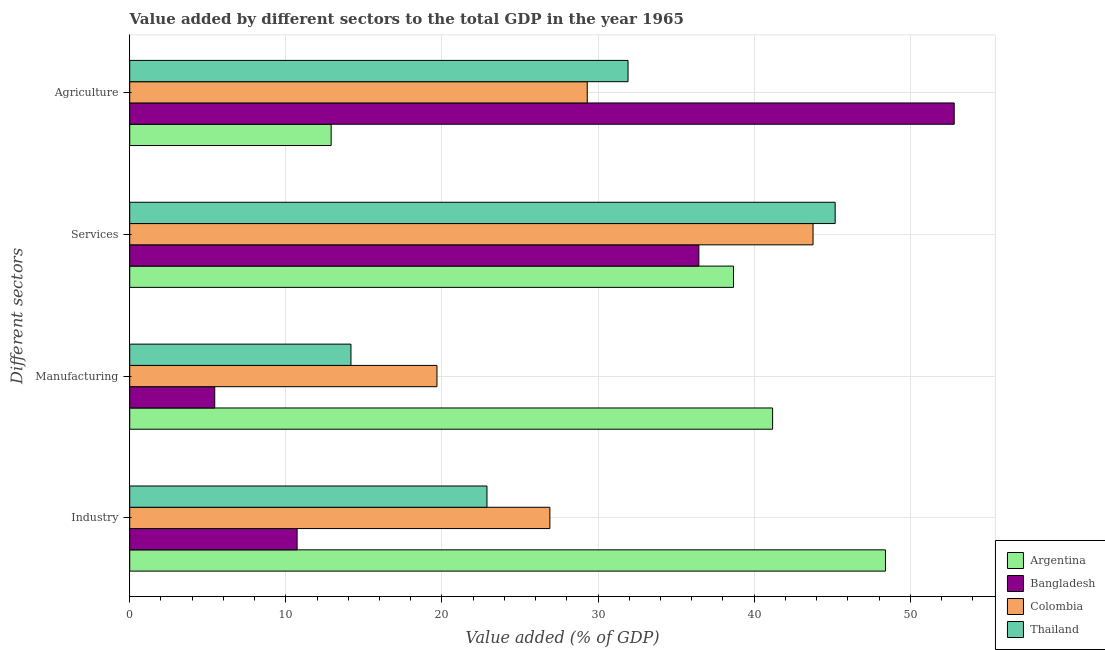How many different coloured bars are there?
Your answer should be compact. 4. How many groups of bars are there?
Provide a short and direct response. 4. Are the number of bars on each tick of the Y-axis equal?
Offer a terse response. Yes. What is the label of the 1st group of bars from the top?
Offer a terse response. Agriculture. What is the value added by services sector in Colombia?
Offer a very short reply. 43.77. Across all countries, what is the maximum value added by industrial sector?
Provide a succinct answer. 48.41. Across all countries, what is the minimum value added by industrial sector?
Give a very brief answer. 10.72. In which country was the value added by manufacturing sector minimum?
Give a very brief answer. Bangladesh. What is the total value added by manufacturing sector in the graph?
Ensure brevity in your answer.  80.48. What is the difference between the value added by manufacturing sector in Argentina and that in Colombia?
Your response must be concise. 21.5. What is the difference between the value added by manufacturing sector in Bangladesh and the value added by agricultural sector in Argentina?
Make the answer very short. -7.46. What is the average value added by industrial sector per country?
Give a very brief answer. 27.23. What is the difference between the value added by manufacturing sector and value added by services sector in Thailand?
Your answer should be very brief. -31.02. In how many countries, is the value added by agricultural sector greater than 24 %?
Your answer should be very brief. 3. What is the ratio of the value added by agricultural sector in Thailand to that in Argentina?
Your response must be concise. 2.47. Is the value added by agricultural sector in Colombia less than that in Thailand?
Your answer should be very brief. Yes. What is the difference between the highest and the second highest value added by industrial sector?
Ensure brevity in your answer.  21.5. What is the difference between the highest and the lowest value added by manufacturing sector?
Your answer should be very brief. 35.74. In how many countries, is the value added by services sector greater than the average value added by services sector taken over all countries?
Make the answer very short. 2. Is it the case that in every country, the sum of the value added by agricultural sector and value added by manufacturing sector is greater than the sum of value added by industrial sector and value added by services sector?
Your answer should be compact. No. What does the 1st bar from the top in Agriculture represents?
Offer a very short reply. Thailand. What does the 4th bar from the bottom in Services represents?
Ensure brevity in your answer.  Thailand. Is it the case that in every country, the sum of the value added by industrial sector and value added by manufacturing sector is greater than the value added by services sector?
Your answer should be compact. No. Are all the bars in the graph horizontal?
Provide a succinct answer. Yes. Are the values on the major ticks of X-axis written in scientific E-notation?
Provide a succinct answer. No. How are the legend labels stacked?
Provide a short and direct response. Vertical. What is the title of the graph?
Make the answer very short. Value added by different sectors to the total GDP in the year 1965. Does "Armenia" appear as one of the legend labels in the graph?
Provide a short and direct response. No. What is the label or title of the X-axis?
Your response must be concise. Value added (% of GDP). What is the label or title of the Y-axis?
Provide a succinct answer. Different sectors. What is the Value added (% of GDP) in Argentina in Industry?
Your response must be concise. 48.41. What is the Value added (% of GDP) of Bangladesh in Industry?
Your answer should be compact. 10.72. What is the Value added (% of GDP) in Colombia in Industry?
Give a very brief answer. 26.92. What is the Value added (% of GDP) of Thailand in Industry?
Make the answer very short. 22.89. What is the Value added (% of GDP) of Argentina in Manufacturing?
Provide a short and direct response. 41.18. What is the Value added (% of GDP) of Bangladesh in Manufacturing?
Give a very brief answer. 5.45. What is the Value added (% of GDP) of Colombia in Manufacturing?
Offer a terse response. 19.68. What is the Value added (% of GDP) in Thailand in Manufacturing?
Your response must be concise. 14.17. What is the Value added (% of GDP) in Argentina in Services?
Your answer should be very brief. 38.68. What is the Value added (% of GDP) in Bangladesh in Services?
Ensure brevity in your answer.  36.46. What is the Value added (% of GDP) of Colombia in Services?
Offer a terse response. 43.77. What is the Value added (% of GDP) in Thailand in Services?
Provide a short and direct response. 45.19. What is the Value added (% of GDP) in Argentina in Agriculture?
Your response must be concise. 12.9. What is the Value added (% of GDP) in Bangladesh in Agriculture?
Offer a terse response. 52.82. What is the Value added (% of GDP) in Colombia in Agriculture?
Make the answer very short. 29.31. What is the Value added (% of GDP) of Thailand in Agriculture?
Your answer should be very brief. 31.92. Across all Different sectors, what is the maximum Value added (% of GDP) in Argentina?
Keep it short and to the point. 48.41. Across all Different sectors, what is the maximum Value added (% of GDP) of Bangladesh?
Give a very brief answer. 52.82. Across all Different sectors, what is the maximum Value added (% of GDP) of Colombia?
Your response must be concise. 43.77. Across all Different sectors, what is the maximum Value added (% of GDP) of Thailand?
Give a very brief answer. 45.19. Across all Different sectors, what is the minimum Value added (% of GDP) in Argentina?
Your response must be concise. 12.9. Across all Different sectors, what is the minimum Value added (% of GDP) of Bangladesh?
Give a very brief answer. 5.45. Across all Different sectors, what is the minimum Value added (% of GDP) in Colombia?
Make the answer very short. 19.68. Across all Different sectors, what is the minimum Value added (% of GDP) in Thailand?
Provide a succinct answer. 14.17. What is the total Value added (% of GDP) in Argentina in the graph?
Make the answer very short. 141.18. What is the total Value added (% of GDP) in Bangladesh in the graph?
Offer a very short reply. 105.45. What is the total Value added (% of GDP) in Colombia in the graph?
Ensure brevity in your answer.  119.68. What is the total Value added (% of GDP) of Thailand in the graph?
Provide a short and direct response. 114.17. What is the difference between the Value added (% of GDP) of Argentina in Industry and that in Manufacturing?
Ensure brevity in your answer.  7.23. What is the difference between the Value added (% of GDP) of Bangladesh in Industry and that in Manufacturing?
Your answer should be very brief. 5.28. What is the difference between the Value added (% of GDP) in Colombia in Industry and that in Manufacturing?
Give a very brief answer. 7.23. What is the difference between the Value added (% of GDP) in Thailand in Industry and that in Manufacturing?
Make the answer very short. 8.71. What is the difference between the Value added (% of GDP) in Argentina in Industry and that in Services?
Give a very brief answer. 9.73. What is the difference between the Value added (% of GDP) in Bangladesh in Industry and that in Services?
Your answer should be very brief. -25.74. What is the difference between the Value added (% of GDP) in Colombia in Industry and that in Services?
Give a very brief answer. -16.86. What is the difference between the Value added (% of GDP) of Thailand in Industry and that in Services?
Provide a short and direct response. -22.31. What is the difference between the Value added (% of GDP) of Argentina in Industry and that in Agriculture?
Provide a succinct answer. 35.51. What is the difference between the Value added (% of GDP) in Bangladesh in Industry and that in Agriculture?
Keep it short and to the point. -42.1. What is the difference between the Value added (% of GDP) in Colombia in Industry and that in Agriculture?
Offer a very short reply. -2.39. What is the difference between the Value added (% of GDP) in Thailand in Industry and that in Agriculture?
Offer a very short reply. -9.04. What is the difference between the Value added (% of GDP) in Argentina in Manufacturing and that in Services?
Your response must be concise. 2.5. What is the difference between the Value added (% of GDP) of Bangladesh in Manufacturing and that in Services?
Ensure brevity in your answer.  -31.01. What is the difference between the Value added (% of GDP) in Colombia in Manufacturing and that in Services?
Ensure brevity in your answer.  -24.09. What is the difference between the Value added (% of GDP) of Thailand in Manufacturing and that in Services?
Make the answer very short. -31.02. What is the difference between the Value added (% of GDP) of Argentina in Manufacturing and that in Agriculture?
Ensure brevity in your answer.  28.28. What is the difference between the Value added (% of GDP) of Bangladesh in Manufacturing and that in Agriculture?
Provide a succinct answer. -47.37. What is the difference between the Value added (% of GDP) in Colombia in Manufacturing and that in Agriculture?
Offer a terse response. -9.63. What is the difference between the Value added (% of GDP) of Thailand in Manufacturing and that in Agriculture?
Ensure brevity in your answer.  -17.75. What is the difference between the Value added (% of GDP) in Argentina in Services and that in Agriculture?
Ensure brevity in your answer.  25.78. What is the difference between the Value added (% of GDP) of Bangladesh in Services and that in Agriculture?
Provide a short and direct response. -16.36. What is the difference between the Value added (% of GDP) in Colombia in Services and that in Agriculture?
Your answer should be compact. 14.46. What is the difference between the Value added (% of GDP) in Thailand in Services and that in Agriculture?
Keep it short and to the point. 13.27. What is the difference between the Value added (% of GDP) in Argentina in Industry and the Value added (% of GDP) in Bangladesh in Manufacturing?
Offer a terse response. 42.97. What is the difference between the Value added (% of GDP) in Argentina in Industry and the Value added (% of GDP) in Colombia in Manufacturing?
Give a very brief answer. 28.73. What is the difference between the Value added (% of GDP) in Argentina in Industry and the Value added (% of GDP) in Thailand in Manufacturing?
Your answer should be very brief. 34.24. What is the difference between the Value added (% of GDP) of Bangladesh in Industry and the Value added (% of GDP) of Colombia in Manufacturing?
Make the answer very short. -8.96. What is the difference between the Value added (% of GDP) in Bangladesh in Industry and the Value added (% of GDP) in Thailand in Manufacturing?
Your response must be concise. -3.45. What is the difference between the Value added (% of GDP) in Colombia in Industry and the Value added (% of GDP) in Thailand in Manufacturing?
Offer a very short reply. 12.74. What is the difference between the Value added (% of GDP) in Argentina in Industry and the Value added (% of GDP) in Bangladesh in Services?
Offer a very short reply. 11.96. What is the difference between the Value added (% of GDP) of Argentina in Industry and the Value added (% of GDP) of Colombia in Services?
Your answer should be compact. 4.64. What is the difference between the Value added (% of GDP) in Argentina in Industry and the Value added (% of GDP) in Thailand in Services?
Provide a succinct answer. 3.22. What is the difference between the Value added (% of GDP) in Bangladesh in Industry and the Value added (% of GDP) in Colombia in Services?
Provide a succinct answer. -33.05. What is the difference between the Value added (% of GDP) of Bangladesh in Industry and the Value added (% of GDP) of Thailand in Services?
Make the answer very short. -34.47. What is the difference between the Value added (% of GDP) in Colombia in Industry and the Value added (% of GDP) in Thailand in Services?
Provide a short and direct response. -18.28. What is the difference between the Value added (% of GDP) of Argentina in Industry and the Value added (% of GDP) of Bangladesh in Agriculture?
Make the answer very short. -4.4. What is the difference between the Value added (% of GDP) in Argentina in Industry and the Value added (% of GDP) in Colombia in Agriculture?
Give a very brief answer. 19.1. What is the difference between the Value added (% of GDP) in Argentina in Industry and the Value added (% of GDP) in Thailand in Agriculture?
Your answer should be very brief. 16.49. What is the difference between the Value added (% of GDP) of Bangladesh in Industry and the Value added (% of GDP) of Colombia in Agriculture?
Keep it short and to the point. -18.59. What is the difference between the Value added (% of GDP) in Bangladesh in Industry and the Value added (% of GDP) in Thailand in Agriculture?
Offer a very short reply. -21.2. What is the difference between the Value added (% of GDP) in Colombia in Industry and the Value added (% of GDP) in Thailand in Agriculture?
Give a very brief answer. -5.01. What is the difference between the Value added (% of GDP) in Argentina in Manufacturing and the Value added (% of GDP) in Bangladesh in Services?
Keep it short and to the point. 4.73. What is the difference between the Value added (% of GDP) in Argentina in Manufacturing and the Value added (% of GDP) in Colombia in Services?
Give a very brief answer. -2.59. What is the difference between the Value added (% of GDP) of Argentina in Manufacturing and the Value added (% of GDP) of Thailand in Services?
Offer a very short reply. -4.01. What is the difference between the Value added (% of GDP) of Bangladesh in Manufacturing and the Value added (% of GDP) of Colombia in Services?
Provide a short and direct response. -38.33. What is the difference between the Value added (% of GDP) in Bangladesh in Manufacturing and the Value added (% of GDP) in Thailand in Services?
Provide a short and direct response. -39.75. What is the difference between the Value added (% of GDP) in Colombia in Manufacturing and the Value added (% of GDP) in Thailand in Services?
Make the answer very short. -25.51. What is the difference between the Value added (% of GDP) in Argentina in Manufacturing and the Value added (% of GDP) in Bangladesh in Agriculture?
Give a very brief answer. -11.63. What is the difference between the Value added (% of GDP) of Argentina in Manufacturing and the Value added (% of GDP) of Colombia in Agriculture?
Give a very brief answer. 11.87. What is the difference between the Value added (% of GDP) in Argentina in Manufacturing and the Value added (% of GDP) in Thailand in Agriculture?
Offer a terse response. 9.26. What is the difference between the Value added (% of GDP) in Bangladesh in Manufacturing and the Value added (% of GDP) in Colombia in Agriculture?
Your answer should be compact. -23.86. What is the difference between the Value added (% of GDP) of Bangladesh in Manufacturing and the Value added (% of GDP) of Thailand in Agriculture?
Your answer should be very brief. -26.48. What is the difference between the Value added (% of GDP) in Colombia in Manufacturing and the Value added (% of GDP) in Thailand in Agriculture?
Offer a very short reply. -12.24. What is the difference between the Value added (% of GDP) of Argentina in Services and the Value added (% of GDP) of Bangladesh in Agriculture?
Ensure brevity in your answer.  -14.14. What is the difference between the Value added (% of GDP) in Argentina in Services and the Value added (% of GDP) in Colombia in Agriculture?
Give a very brief answer. 9.37. What is the difference between the Value added (% of GDP) in Argentina in Services and the Value added (% of GDP) in Thailand in Agriculture?
Provide a short and direct response. 6.76. What is the difference between the Value added (% of GDP) of Bangladesh in Services and the Value added (% of GDP) of Colombia in Agriculture?
Your answer should be compact. 7.15. What is the difference between the Value added (% of GDP) in Bangladesh in Services and the Value added (% of GDP) in Thailand in Agriculture?
Make the answer very short. 4.54. What is the difference between the Value added (% of GDP) in Colombia in Services and the Value added (% of GDP) in Thailand in Agriculture?
Offer a terse response. 11.85. What is the average Value added (% of GDP) in Argentina per Different sectors?
Your answer should be very brief. 35.3. What is the average Value added (% of GDP) in Bangladesh per Different sectors?
Your answer should be compact. 26.36. What is the average Value added (% of GDP) of Colombia per Different sectors?
Your response must be concise. 29.92. What is the average Value added (% of GDP) in Thailand per Different sectors?
Your response must be concise. 28.54. What is the difference between the Value added (% of GDP) of Argentina and Value added (% of GDP) of Bangladesh in Industry?
Your answer should be very brief. 37.69. What is the difference between the Value added (% of GDP) in Argentina and Value added (% of GDP) in Colombia in Industry?
Offer a terse response. 21.5. What is the difference between the Value added (% of GDP) in Argentina and Value added (% of GDP) in Thailand in Industry?
Keep it short and to the point. 25.53. What is the difference between the Value added (% of GDP) of Bangladesh and Value added (% of GDP) of Colombia in Industry?
Provide a succinct answer. -16.19. What is the difference between the Value added (% of GDP) of Bangladesh and Value added (% of GDP) of Thailand in Industry?
Offer a very short reply. -12.16. What is the difference between the Value added (% of GDP) in Colombia and Value added (% of GDP) in Thailand in Industry?
Offer a very short reply. 4.03. What is the difference between the Value added (% of GDP) of Argentina and Value added (% of GDP) of Bangladesh in Manufacturing?
Your answer should be very brief. 35.74. What is the difference between the Value added (% of GDP) in Argentina and Value added (% of GDP) in Colombia in Manufacturing?
Ensure brevity in your answer.  21.5. What is the difference between the Value added (% of GDP) of Argentina and Value added (% of GDP) of Thailand in Manufacturing?
Provide a short and direct response. 27.01. What is the difference between the Value added (% of GDP) of Bangladesh and Value added (% of GDP) of Colombia in Manufacturing?
Your answer should be very brief. -14.24. What is the difference between the Value added (% of GDP) of Bangladesh and Value added (% of GDP) of Thailand in Manufacturing?
Offer a very short reply. -8.73. What is the difference between the Value added (% of GDP) of Colombia and Value added (% of GDP) of Thailand in Manufacturing?
Provide a short and direct response. 5.51. What is the difference between the Value added (% of GDP) of Argentina and Value added (% of GDP) of Bangladesh in Services?
Give a very brief answer. 2.22. What is the difference between the Value added (% of GDP) of Argentina and Value added (% of GDP) of Colombia in Services?
Offer a terse response. -5.09. What is the difference between the Value added (% of GDP) of Argentina and Value added (% of GDP) of Thailand in Services?
Provide a short and direct response. -6.51. What is the difference between the Value added (% of GDP) in Bangladesh and Value added (% of GDP) in Colombia in Services?
Offer a terse response. -7.32. What is the difference between the Value added (% of GDP) of Bangladesh and Value added (% of GDP) of Thailand in Services?
Your answer should be compact. -8.73. What is the difference between the Value added (% of GDP) of Colombia and Value added (% of GDP) of Thailand in Services?
Your answer should be very brief. -1.42. What is the difference between the Value added (% of GDP) in Argentina and Value added (% of GDP) in Bangladesh in Agriculture?
Give a very brief answer. -39.91. What is the difference between the Value added (% of GDP) of Argentina and Value added (% of GDP) of Colombia in Agriculture?
Offer a very short reply. -16.41. What is the difference between the Value added (% of GDP) of Argentina and Value added (% of GDP) of Thailand in Agriculture?
Give a very brief answer. -19.02. What is the difference between the Value added (% of GDP) of Bangladesh and Value added (% of GDP) of Colombia in Agriculture?
Your answer should be very brief. 23.51. What is the difference between the Value added (% of GDP) of Bangladesh and Value added (% of GDP) of Thailand in Agriculture?
Your answer should be compact. 20.9. What is the difference between the Value added (% of GDP) in Colombia and Value added (% of GDP) in Thailand in Agriculture?
Keep it short and to the point. -2.61. What is the ratio of the Value added (% of GDP) of Argentina in Industry to that in Manufacturing?
Offer a terse response. 1.18. What is the ratio of the Value added (% of GDP) in Bangladesh in Industry to that in Manufacturing?
Provide a short and direct response. 1.97. What is the ratio of the Value added (% of GDP) of Colombia in Industry to that in Manufacturing?
Ensure brevity in your answer.  1.37. What is the ratio of the Value added (% of GDP) in Thailand in Industry to that in Manufacturing?
Keep it short and to the point. 1.61. What is the ratio of the Value added (% of GDP) in Argentina in Industry to that in Services?
Your answer should be compact. 1.25. What is the ratio of the Value added (% of GDP) in Bangladesh in Industry to that in Services?
Your answer should be compact. 0.29. What is the ratio of the Value added (% of GDP) in Colombia in Industry to that in Services?
Offer a very short reply. 0.61. What is the ratio of the Value added (% of GDP) in Thailand in Industry to that in Services?
Give a very brief answer. 0.51. What is the ratio of the Value added (% of GDP) of Argentina in Industry to that in Agriculture?
Keep it short and to the point. 3.75. What is the ratio of the Value added (% of GDP) in Bangladesh in Industry to that in Agriculture?
Offer a very short reply. 0.2. What is the ratio of the Value added (% of GDP) in Colombia in Industry to that in Agriculture?
Your answer should be very brief. 0.92. What is the ratio of the Value added (% of GDP) in Thailand in Industry to that in Agriculture?
Provide a short and direct response. 0.72. What is the ratio of the Value added (% of GDP) in Argentina in Manufacturing to that in Services?
Offer a terse response. 1.06. What is the ratio of the Value added (% of GDP) of Bangladesh in Manufacturing to that in Services?
Your answer should be very brief. 0.15. What is the ratio of the Value added (% of GDP) in Colombia in Manufacturing to that in Services?
Provide a succinct answer. 0.45. What is the ratio of the Value added (% of GDP) in Thailand in Manufacturing to that in Services?
Provide a succinct answer. 0.31. What is the ratio of the Value added (% of GDP) of Argentina in Manufacturing to that in Agriculture?
Your response must be concise. 3.19. What is the ratio of the Value added (% of GDP) in Bangladesh in Manufacturing to that in Agriculture?
Provide a succinct answer. 0.1. What is the ratio of the Value added (% of GDP) of Colombia in Manufacturing to that in Agriculture?
Offer a terse response. 0.67. What is the ratio of the Value added (% of GDP) of Thailand in Manufacturing to that in Agriculture?
Your answer should be compact. 0.44. What is the ratio of the Value added (% of GDP) in Argentina in Services to that in Agriculture?
Offer a terse response. 3. What is the ratio of the Value added (% of GDP) in Bangladesh in Services to that in Agriculture?
Provide a short and direct response. 0.69. What is the ratio of the Value added (% of GDP) in Colombia in Services to that in Agriculture?
Keep it short and to the point. 1.49. What is the ratio of the Value added (% of GDP) of Thailand in Services to that in Agriculture?
Offer a very short reply. 1.42. What is the difference between the highest and the second highest Value added (% of GDP) of Argentina?
Offer a terse response. 7.23. What is the difference between the highest and the second highest Value added (% of GDP) in Bangladesh?
Keep it short and to the point. 16.36. What is the difference between the highest and the second highest Value added (% of GDP) of Colombia?
Provide a short and direct response. 14.46. What is the difference between the highest and the second highest Value added (% of GDP) of Thailand?
Give a very brief answer. 13.27. What is the difference between the highest and the lowest Value added (% of GDP) in Argentina?
Provide a short and direct response. 35.51. What is the difference between the highest and the lowest Value added (% of GDP) of Bangladesh?
Your answer should be very brief. 47.37. What is the difference between the highest and the lowest Value added (% of GDP) in Colombia?
Offer a terse response. 24.09. What is the difference between the highest and the lowest Value added (% of GDP) of Thailand?
Keep it short and to the point. 31.02. 